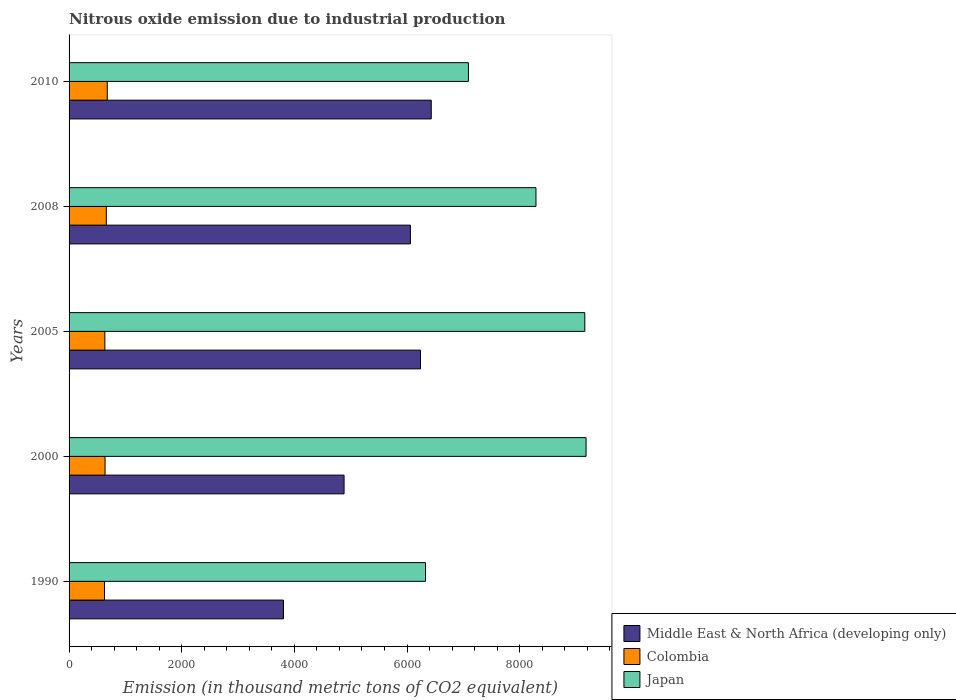How many different coloured bars are there?
Provide a short and direct response. 3. How many groups of bars are there?
Provide a short and direct response. 5. Are the number of bars per tick equal to the number of legend labels?
Give a very brief answer. Yes. How many bars are there on the 3rd tick from the bottom?
Make the answer very short. 3. In how many cases, is the number of bars for a given year not equal to the number of legend labels?
Keep it short and to the point. 0. What is the amount of nitrous oxide emitted in Colombia in 2010?
Make the answer very short. 678.2. Across all years, what is the maximum amount of nitrous oxide emitted in Middle East & North Africa (developing only)?
Provide a succinct answer. 6430.5. Across all years, what is the minimum amount of nitrous oxide emitted in Japan?
Provide a short and direct response. 6328.4. What is the total amount of nitrous oxide emitted in Colombia in the graph?
Make the answer very short. 3242.5. What is the difference between the amount of nitrous oxide emitted in Japan in 2000 and that in 2010?
Offer a terse response. 2088.8. What is the difference between the amount of nitrous oxide emitted in Colombia in 2010 and the amount of nitrous oxide emitted in Middle East & North Africa (developing only) in 2008?
Provide a short and direct response. -5382. What is the average amount of nitrous oxide emitted in Colombia per year?
Your answer should be compact. 648.5. In the year 2010, what is the difference between the amount of nitrous oxide emitted in Colombia and amount of nitrous oxide emitted in Japan?
Provide a succinct answer. -6412.4. In how many years, is the amount of nitrous oxide emitted in Colombia greater than 5200 thousand metric tons?
Keep it short and to the point. 0. What is the ratio of the amount of nitrous oxide emitted in Middle East & North Africa (developing only) in 2008 to that in 2010?
Offer a terse response. 0.94. Is the difference between the amount of nitrous oxide emitted in Colombia in 2005 and 2008 greater than the difference between the amount of nitrous oxide emitted in Japan in 2005 and 2008?
Your answer should be very brief. No. What is the difference between the highest and the second highest amount of nitrous oxide emitted in Middle East & North Africa (developing only)?
Your answer should be compact. 190.9. What is the difference between the highest and the lowest amount of nitrous oxide emitted in Japan?
Offer a very short reply. 2851. Is the sum of the amount of nitrous oxide emitted in Colombia in 2008 and 2010 greater than the maximum amount of nitrous oxide emitted in Japan across all years?
Your answer should be very brief. No. What does the 1st bar from the bottom in 2008 represents?
Make the answer very short. Middle East & North Africa (developing only). How many bars are there?
Ensure brevity in your answer.  15. Are all the bars in the graph horizontal?
Your answer should be very brief. Yes. Does the graph contain any zero values?
Provide a short and direct response. No. Does the graph contain grids?
Offer a terse response. No. How are the legend labels stacked?
Keep it short and to the point. Vertical. What is the title of the graph?
Offer a very short reply. Nitrous oxide emission due to industrial production. What is the label or title of the X-axis?
Ensure brevity in your answer.  Emission (in thousand metric tons of CO2 equivalent). What is the label or title of the Y-axis?
Your answer should be compact. Years. What is the Emission (in thousand metric tons of CO2 equivalent) in Middle East & North Africa (developing only) in 1990?
Your response must be concise. 3806.6. What is the Emission (in thousand metric tons of CO2 equivalent) of Colombia in 1990?
Offer a terse response. 629.1. What is the Emission (in thousand metric tons of CO2 equivalent) in Japan in 1990?
Give a very brief answer. 6328.4. What is the Emission (in thousand metric tons of CO2 equivalent) of Middle East & North Africa (developing only) in 2000?
Your answer should be very brief. 4882.9. What is the Emission (in thousand metric tons of CO2 equivalent) of Colombia in 2000?
Your response must be concise. 638.8. What is the Emission (in thousand metric tons of CO2 equivalent) in Japan in 2000?
Offer a very short reply. 9179.4. What is the Emission (in thousand metric tons of CO2 equivalent) in Middle East & North Africa (developing only) in 2005?
Offer a terse response. 6239.6. What is the Emission (in thousand metric tons of CO2 equivalent) in Colombia in 2005?
Give a very brief answer. 635.3. What is the Emission (in thousand metric tons of CO2 equivalent) in Japan in 2005?
Give a very brief answer. 9157. What is the Emission (in thousand metric tons of CO2 equivalent) in Middle East & North Africa (developing only) in 2008?
Make the answer very short. 6060.2. What is the Emission (in thousand metric tons of CO2 equivalent) in Colombia in 2008?
Provide a succinct answer. 661.1. What is the Emission (in thousand metric tons of CO2 equivalent) in Japan in 2008?
Your response must be concise. 8290. What is the Emission (in thousand metric tons of CO2 equivalent) in Middle East & North Africa (developing only) in 2010?
Make the answer very short. 6430.5. What is the Emission (in thousand metric tons of CO2 equivalent) of Colombia in 2010?
Offer a very short reply. 678.2. What is the Emission (in thousand metric tons of CO2 equivalent) in Japan in 2010?
Your response must be concise. 7090.6. Across all years, what is the maximum Emission (in thousand metric tons of CO2 equivalent) in Middle East & North Africa (developing only)?
Keep it short and to the point. 6430.5. Across all years, what is the maximum Emission (in thousand metric tons of CO2 equivalent) in Colombia?
Give a very brief answer. 678.2. Across all years, what is the maximum Emission (in thousand metric tons of CO2 equivalent) of Japan?
Your response must be concise. 9179.4. Across all years, what is the minimum Emission (in thousand metric tons of CO2 equivalent) in Middle East & North Africa (developing only)?
Your answer should be compact. 3806.6. Across all years, what is the minimum Emission (in thousand metric tons of CO2 equivalent) of Colombia?
Offer a terse response. 629.1. Across all years, what is the minimum Emission (in thousand metric tons of CO2 equivalent) in Japan?
Ensure brevity in your answer.  6328.4. What is the total Emission (in thousand metric tons of CO2 equivalent) of Middle East & North Africa (developing only) in the graph?
Your response must be concise. 2.74e+04. What is the total Emission (in thousand metric tons of CO2 equivalent) in Colombia in the graph?
Provide a short and direct response. 3242.5. What is the total Emission (in thousand metric tons of CO2 equivalent) of Japan in the graph?
Provide a short and direct response. 4.00e+04. What is the difference between the Emission (in thousand metric tons of CO2 equivalent) of Middle East & North Africa (developing only) in 1990 and that in 2000?
Offer a very short reply. -1076.3. What is the difference between the Emission (in thousand metric tons of CO2 equivalent) of Colombia in 1990 and that in 2000?
Keep it short and to the point. -9.7. What is the difference between the Emission (in thousand metric tons of CO2 equivalent) in Japan in 1990 and that in 2000?
Offer a very short reply. -2851. What is the difference between the Emission (in thousand metric tons of CO2 equivalent) in Middle East & North Africa (developing only) in 1990 and that in 2005?
Ensure brevity in your answer.  -2433. What is the difference between the Emission (in thousand metric tons of CO2 equivalent) of Japan in 1990 and that in 2005?
Your answer should be very brief. -2828.6. What is the difference between the Emission (in thousand metric tons of CO2 equivalent) in Middle East & North Africa (developing only) in 1990 and that in 2008?
Provide a succinct answer. -2253.6. What is the difference between the Emission (in thousand metric tons of CO2 equivalent) in Colombia in 1990 and that in 2008?
Offer a terse response. -32. What is the difference between the Emission (in thousand metric tons of CO2 equivalent) of Japan in 1990 and that in 2008?
Keep it short and to the point. -1961.6. What is the difference between the Emission (in thousand metric tons of CO2 equivalent) in Middle East & North Africa (developing only) in 1990 and that in 2010?
Keep it short and to the point. -2623.9. What is the difference between the Emission (in thousand metric tons of CO2 equivalent) in Colombia in 1990 and that in 2010?
Your answer should be very brief. -49.1. What is the difference between the Emission (in thousand metric tons of CO2 equivalent) of Japan in 1990 and that in 2010?
Your answer should be very brief. -762.2. What is the difference between the Emission (in thousand metric tons of CO2 equivalent) in Middle East & North Africa (developing only) in 2000 and that in 2005?
Offer a very short reply. -1356.7. What is the difference between the Emission (in thousand metric tons of CO2 equivalent) in Japan in 2000 and that in 2005?
Provide a short and direct response. 22.4. What is the difference between the Emission (in thousand metric tons of CO2 equivalent) in Middle East & North Africa (developing only) in 2000 and that in 2008?
Offer a very short reply. -1177.3. What is the difference between the Emission (in thousand metric tons of CO2 equivalent) in Colombia in 2000 and that in 2008?
Ensure brevity in your answer.  -22.3. What is the difference between the Emission (in thousand metric tons of CO2 equivalent) in Japan in 2000 and that in 2008?
Offer a very short reply. 889.4. What is the difference between the Emission (in thousand metric tons of CO2 equivalent) of Middle East & North Africa (developing only) in 2000 and that in 2010?
Provide a short and direct response. -1547.6. What is the difference between the Emission (in thousand metric tons of CO2 equivalent) in Colombia in 2000 and that in 2010?
Give a very brief answer. -39.4. What is the difference between the Emission (in thousand metric tons of CO2 equivalent) of Japan in 2000 and that in 2010?
Offer a very short reply. 2088.8. What is the difference between the Emission (in thousand metric tons of CO2 equivalent) in Middle East & North Africa (developing only) in 2005 and that in 2008?
Your answer should be very brief. 179.4. What is the difference between the Emission (in thousand metric tons of CO2 equivalent) in Colombia in 2005 and that in 2008?
Make the answer very short. -25.8. What is the difference between the Emission (in thousand metric tons of CO2 equivalent) of Japan in 2005 and that in 2008?
Give a very brief answer. 867. What is the difference between the Emission (in thousand metric tons of CO2 equivalent) of Middle East & North Africa (developing only) in 2005 and that in 2010?
Give a very brief answer. -190.9. What is the difference between the Emission (in thousand metric tons of CO2 equivalent) of Colombia in 2005 and that in 2010?
Your response must be concise. -42.9. What is the difference between the Emission (in thousand metric tons of CO2 equivalent) in Japan in 2005 and that in 2010?
Give a very brief answer. 2066.4. What is the difference between the Emission (in thousand metric tons of CO2 equivalent) of Middle East & North Africa (developing only) in 2008 and that in 2010?
Provide a succinct answer. -370.3. What is the difference between the Emission (in thousand metric tons of CO2 equivalent) in Colombia in 2008 and that in 2010?
Offer a very short reply. -17.1. What is the difference between the Emission (in thousand metric tons of CO2 equivalent) of Japan in 2008 and that in 2010?
Give a very brief answer. 1199.4. What is the difference between the Emission (in thousand metric tons of CO2 equivalent) in Middle East & North Africa (developing only) in 1990 and the Emission (in thousand metric tons of CO2 equivalent) in Colombia in 2000?
Offer a very short reply. 3167.8. What is the difference between the Emission (in thousand metric tons of CO2 equivalent) of Middle East & North Africa (developing only) in 1990 and the Emission (in thousand metric tons of CO2 equivalent) of Japan in 2000?
Ensure brevity in your answer.  -5372.8. What is the difference between the Emission (in thousand metric tons of CO2 equivalent) of Colombia in 1990 and the Emission (in thousand metric tons of CO2 equivalent) of Japan in 2000?
Keep it short and to the point. -8550.3. What is the difference between the Emission (in thousand metric tons of CO2 equivalent) of Middle East & North Africa (developing only) in 1990 and the Emission (in thousand metric tons of CO2 equivalent) of Colombia in 2005?
Your answer should be very brief. 3171.3. What is the difference between the Emission (in thousand metric tons of CO2 equivalent) of Middle East & North Africa (developing only) in 1990 and the Emission (in thousand metric tons of CO2 equivalent) of Japan in 2005?
Offer a terse response. -5350.4. What is the difference between the Emission (in thousand metric tons of CO2 equivalent) in Colombia in 1990 and the Emission (in thousand metric tons of CO2 equivalent) in Japan in 2005?
Provide a succinct answer. -8527.9. What is the difference between the Emission (in thousand metric tons of CO2 equivalent) in Middle East & North Africa (developing only) in 1990 and the Emission (in thousand metric tons of CO2 equivalent) in Colombia in 2008?
Ensure brevity in your answer.  3145.5. What is the difference between the Emission (in thousand metric tons of CO2 equivalent) in Middle East & North Africa (developing only) in 1990 and the Emission (in thousand metric tons of CO2 equivalent) in Japan in 2008?
Your answer should be very brief. -4483.4. What is the difference between the Emission (in thousand metric tons of CO2 equivalent) of Colombia in 1990 and the Emission (in thousand metric tons of CO2 equivalent) of Japan in 2008?
Offer a very short reply. -7660.9. What is the difference between the Emission (in thousand metric tons of CO2 equivalent) in Middle East & North Africa (developing only) in 1990 and the Emission (in thousand metric tons of CO2 equivalent) in Colombia in 2010?
Give a very brief answer. 3128.4. What is the difference between the Emission (in thousand metric tons of CO2 equivalent) in Middle East & North Africa (developing only) in 1990 and the Emission (in thousand metric tons of CO2 equivalent) in Japan in 2010?
Your response must be concise. -3284. What is the difference between the Emission (in thousand metric tons of CO2 equivalent) of Colombia in 1990 and the Emission (in thousand metric tons of CO2 equivalent) of Japan in 2010?
Offer a terse response. -6461.5. What is the difference between the Emission (in thousand metric tons of CO2 equivalent) of Middle East & North Africa (developing only) in 2000 and the Emission (in thousand metric tons of CO2 equivalent) of Colombia in 2005?
Provide a short and direct response. 4247.6. What is the difference between the Emission (in thousand metric tons of CO2 equivalent) in Middle East & North Africa (developing only) in 2000 and the Emission (in thousand metric tons of CO2 equivalent) in Japan in 2005?
Give a very brief answer. -4274.1. What is the difference between the Emission (in thousand metric tons of CO2 equivalent) of Colombia in 2000 and the Emission (in thousand metric tons of CO2 equivalent) of Japan in 2005?
Ensure brevity in your answer.  -8518.2. What is the difference between the Emission (in thousand metric tons of CO2 equivalent) of Middle East & North Africa (developing only) in 2000 and the Emission (in thousand metric tons of CO2 equivalent) of Colombia in 2008?
Offer a very short reply. 4221.8. What is the difference between the Emission (in thousand metric tons of CO2 equivalent) in Middle East & North Africa (developing only) in 2000 and the Emission (in thousand metric tons of CO2 equivalent) in Japan in 2008?
Your response must be concise. -3407.1. What is the difference between the Emission (in thousand metric tons of CO2 equivalent) of Colombia in 2000 and the Emission (in thousand metric tons of CO2 equivalent) of Japan in 2008?
Provide a short and direct response. -7651.2. What is the difference between the Emission (in thousand metric tons of CO2 equivalent) in Middle East & North Africa (developing only) in 2000 and the Emission (in thousand metric tons of CO2 equivalent) in Colombia in 2010?
Offer a terse response. 4204.7. What is the difference between the Emission (in thousand metric tons of CO2 equivalent) of Middle East & North Africa (developing only) in 2000 and the Emission (in thousand metric tons of CO2 equivalent) of Japan in 2010?
Provide a short and direct response. -2207.7. What is the difference between the Emission (in thousand metric tons of CO2 equivalent) in Colombia in 2000 and the Emission (in thousand metric tons of CO2 equivalent) in Japan in 2010?
Ensure brevity in your answer.  -6451.8. What is the difference between the Emission (in thousand metric tons of CO2 equivalent) of Middle East & North Africa (developing only) in 2005 and the Emission (in thousand metric tons of CO2 equivalent) of Colombia in 2008?
Make the answer very short. 5578.5. What is the difference between the Emission (in thousand metric tons of CO2 equivalent) in Middle East & North Africa (developing only) in 2005 and the Emission (in thousand metric tons of CO2 equivalent) in Japan in 2008?
Give a very brief answer. -2050.4. What is the difference between the Emission (in thousand metric tons of CO2 equivalent) in Colombia in 2005 and the Emission (in thousand metric tons of CO2 equivalent) in Japan in 2008?
Offer a terse response. -7654.7. What is the difference between the Emission (in thousand metric tons of CO2 equivalent) of Middle East & North Africa (developing only) in 2005 and the Emission (in thousand metric tons of CO2 equivalent) of Colombia in 2010?
Give a very brief answer. 5561.4. What is the difference between the Emission (in thousand metric tons of CO2 equivalent) in Middle East & North Africa (developing only) in 2005 and the Emission (in thousand metric tons of CO2 equivalent) in Japan in 2010?
Your answer should be very brief. -851. What is the difference between the Emission (in thousand metric tons of CO2 equivalent) in Colombia in 2005 and the Emission (in thousand metric tons of CO2 equivalent) in Japan in 2010?
Keep it short and to the point. -6455.3. What is the difference between the Emission (in thousand metric tons of CO2 equivalent) in Middle East & North Africa (developing only) in 2008 and the Emission (in thousand metric tons of CO2 equivalent) in Colombia in 2010?
Keep it short and to the point. 5382. What is the difference between the Emission (in thousand metric tons of CO2 equivalent) in Middle East & North Africa (developing only) in 2008 and the Emission (in thousand metric tons of CO2 equivalent) in Japan in 2010?
Provide a succinct answer. -1030.4. What is the difference between the Emission (in thousand metric tons of CO2 equivalent) of Colombia in 2008 and the Emission (in thousand metric tons of CO2 equivalent) of Japan in 2010?
Keep it short and to the point. -6429.5. What is the average Emission (in thousand metric tons of CO2 equivalent) of Middle East & North Africa (developing only) per year?
Give a very brief answer. 5483.96. What is the average Emission (in thousand metric tons of CO2 equivalent) in Colombia per year?
Keep it short and to the point. 648.5. What is the average Emission (in thousand metric tons of CO2 equivalent) of Japan per year?
Your answer should be compact. 8009.08. In the year 1990, what is the difference between the Emission (in thousand metric tons of CO2 equivalent) in Middle East & North Africa (developing only) and Emission (in thousand metric tons of CO2 equivalent) in Colombia?
Give a very brief answer. 3177.5. In the year 1990, what is the difference between the Emission (in thousand metric tons of CO2 equivalent) of Middle East & North Africa (developing only) and Emission (in thousand metric tons of CO2 equivalent) of Japan?
Provide a short and direct response. -2521.8. In the year 1990, what is the difference between the Emission (in thousand metric tons of CO2 equivalent) in Colombia and Emission (in thousand metric tons of CO2 equivalent) in Japan?
Your answer should be very brief. -5699.3. In the year 2000, what is the difference between the Emission (in thousand metric tons of CO2 equivalent) of Middle East & North Africa (developing only) and Emission (in thousand metric tons of CO2 equivalent) of Colombia?
Provide a short and direct response. 4244.1. In the year 2000, what is the difference between the Emission (in thousand metric tons of CO2 equivalent) in Middle East & North Africa (developing only) and Emission (in thousand metric tons of CO2 equivalent) in Japan?
Your answer should be compact. -4296.5. In the year 2000, what is the difference between the Emission (in thousand metric tons of CO2 equivalent) in Colombia and Emission (in thousand metric tons of CO2 equivalent) in Japan?
Your answer should be compact. -8540.6. In the year 2005, what is the difference between the Emission (in thousand metric tons of CO2 equivalent) of Middle East & North Africa (developing only) and Emission (in thousand metric tons of CO2 equivalent) of Colombia?
Offer a very short reply. 5604.3. In the year 2005, what is the difference between the Emission (in thousand metric tons of CO2 equivalent) in Middle East & North Africa (developing only) and Emission (in thousand metric tons of CO2 equivalent) in Japan?
Your response must be concise. -2917.4. In the year 2005, what is the difference between the Emission (in thousand metric tons of CO2 equivalent) of Colombia and Emission (in thousand metric tons of CO2 equivalent) of Japan?
Your answer should be compact. -8521.7. In the year 2008, what is the difference between the Emission (in thousand metric tons of CO2 equivalent) in Middle East & North Africa (developing only) and Emission (in thousand metric tons of CO2 equivalent) in Colombia?
Provide a short and direct response. 5399.1. In the year 2008, what is the difference between the Emission (in thousand metric tons of CO2 equivalent) in Middle East & North Africa (developing only) and Emission (in thousand metric tons of CO2 equivalent) in Japan?
Make the answer very short. -2229.8. In the year 2008, what is the difference between the Emission (in thousand metric tons of CO2 equivalent) of Colombia and Emission (in thousand metric tons of CO2 equivalent) of Japan?
Your answer should be very brief. -7628.9. In the year 2010, what is the difference between the Emission (in thousand metric tons of CO2 equivalent) in Middle East & North Africa (developing only) and Emission (in thousand metric tons of CO2 equivalent) in Colombia?
Offer a terse response. 5752.3. In the year 2010, what is the difference between the Emission (in thousand metric tons of CO2 equivalent) of Middle East & North Africa (developing only) and Emission (in thousand metric tons of CO2 equivalent) of Japan?
Your answer should be compact. -660.1. In the year 2010, what is the difference between the Emission (in thousand metric tons of CO2 equivalent) of Colombia and Emission (in thousand metric tons of CO2 equivalent) of Japan?
Ensure brevity in your answer.  -6412.4. What is the ratio of the Emission (in thousand metric tons of CO2 equivalent) of Middle East & North Africa (developing only) in 1990 to that in 2000?
Give a very brief answer. 0.78. What is the ratio of the Emission (in thousand metric tons of CO2 equivalent) in Colombia in 1990 to that in 2000?
Provide a short and direct response. 0.98. What is the ratio of the Emission (in thousand metric tons of CO2 equivalent) of Japan in 1990 to that in 2000?
Provide a short and direct response. 0.69. What is the ratio of the Emission (in thousand metric tons of CO2 equivalent) of Middle East & North Africa (developing only) in 1990 to that in 2005?
Provide a short and direct response. 0.61. What is the ratio of the Emission (in thousand metric tons of CO2 equivalent) in Colombia in 1990 to that in 2005?
Offer a very short reply. 0.99. What is the ratio of the Emission (in thousand metric tons of CO2 equivalent) of Japan in 1990 to that in 2005?
Give a very brief answer. 0.69. What is the ratio of the Emission (in thousand metric tons of CO2 equivalent) in Middle East & North Africa (developing only) in 1990 to that in 2008?
Ensure brevity in your answer.  0.63. What is the ratio of the Emission (in thousand metric tons of CO2 equivalent) of Colombia in 1990 to that in 2008?
Make the answer very short. 0.95. What is the ratio of the Emission (in thousand metric tons of CO2 equivalent) in Japan in 1990 to that in 2008?
Offer a terse response. 0.76. What is the ratio of the Emission (in thousand metric tons of CO2 equivalent) in Middle East & North Africa (developing only) in 1990 to that in 2010?
Ensure brevity in your answer.  0.59. What is the ratio of the Emission (in thousand metric tons of CO2 equivalent) of Colombia in 1990 to that in 2010?
Offer a very short reply. 0.93. What is the ratio of the Emission (in thousand metric tons of CO2 equivalent) in Japan in 1990 to that in 2010?
Your response must be concise. 0.89. What is the ratio of the Emission (in thousand metric tons of CO2 equivalent) of Middle East & North Africa (developing only) in 2000 to that in 2005?
Your response must be concise. 0.78. What is the ratio of the Emission (in thousand metric tons of CO2 equivalent) of Middle East & North Africa (developing only) in 2000 to that in 2008?
Provide a succinct answer. 0.81. What is the ratio of the Emission (in thousand metric tons of CO2 equivalent) in Colombia in 2000 to that in 2008?
Provide a succinct answer. 0.97. What is the ratio of the Emission (in thousand metric tons of CO2 equivalent) in Japan in 2000 to that in 2008?
Offer a very short reply. 1.11. What is the ratio of the Emission (in thousand metric tons of CO2 equivalent) in Middle East & North Africa (developing only) in 2000 to that in 2010?
Keep it short and to the point. 0.76. What is the ratio of the Emission (in thousand metric tons of CO2 equivalent) in Colombia in 2000 to that in 2010?
Your answer should be very brief. 0.94. What is the ratio of the Emission (in thousand metric tons of CO2 equivalent) in Japan in 2000 to that in 2010?
Offer a terse response. 1.29. What is the ratio of the Emission (in thousand metric tons of CO2 equivalent) of Middle East & North Africa (developing only) in 2005 to that in 2008?
Your response must be concise. 1.03. What is the ratio of the Emission (in thousand metric tons of CO2 equivalent) of Colombia in 2005 to that in 2008?
Offer a terse response. 0.96. What is the ratio of the Emission (in thousand metric tons of CO2 equivalent) in Japan in 2005 to that in 2008?
Provide a succinct answer. 1.1. What is the ratio of the Emission (in thousand metric tons of CO2 equivalent) of Middle East & North Africa (developing only) in 2005 to that in 2010?
Keep it short and to the point. 0.97. What is the ratio of the Emission (in thousand metric tons of CO2 equivalent) of Colombia in 2005 to that in 2010?
Offer a very short reply. 0.94. What is the ratio of the Emission (in thousand metric tons of CO2 equivalent) in Japan in 2005 to that in 2010?
Keep it short and to the point. 1.29. What is the ratio of the Emission (in thousand metric tons of CO2 equivalent) of Middle East & North Africa (developing only) in 2008 to that in 2010?
Give a very brief answer. 0.94. What is the ratio of the Emission (in thousand metric tons of CO2 equivalent) of Colombia in 2008 to that in 2010?
Your answer should be very brief. 0.97. What is the ratio of the Emission (in thousand metric tons of CO2 equivalent) of Japan in 2008 to that in 2010?
Offer a terse response. 1.17. What is the difference between the highest and the second highest Emission (in thousand metric tons of CO2 equivalent) of Middle East & North Africa (developing only)?
Keep it short and to the point. 190.9. What is the difference between the highest and the second highest Emission (in thousand metric tons of CO2 equivalent) in Japan?
Offer a terse response. 22.4. What is the difference between the highest and the lowest Emission (in thousand metric tons of CO2 equivalent) of Middle East & North Africa (developing only)?
Your answer should be very brief. 2623.9. What is the difference between the highest and the lowest Emission (in thousand metric tons of CO2 equivalent) in Colombia?
Keep it short and to the point. 49.1. What is the difference between the highest and the lowest Emission (in thousand metric tons of CO2 equivalent) in Japan?
Make the answer very short. 2851. 